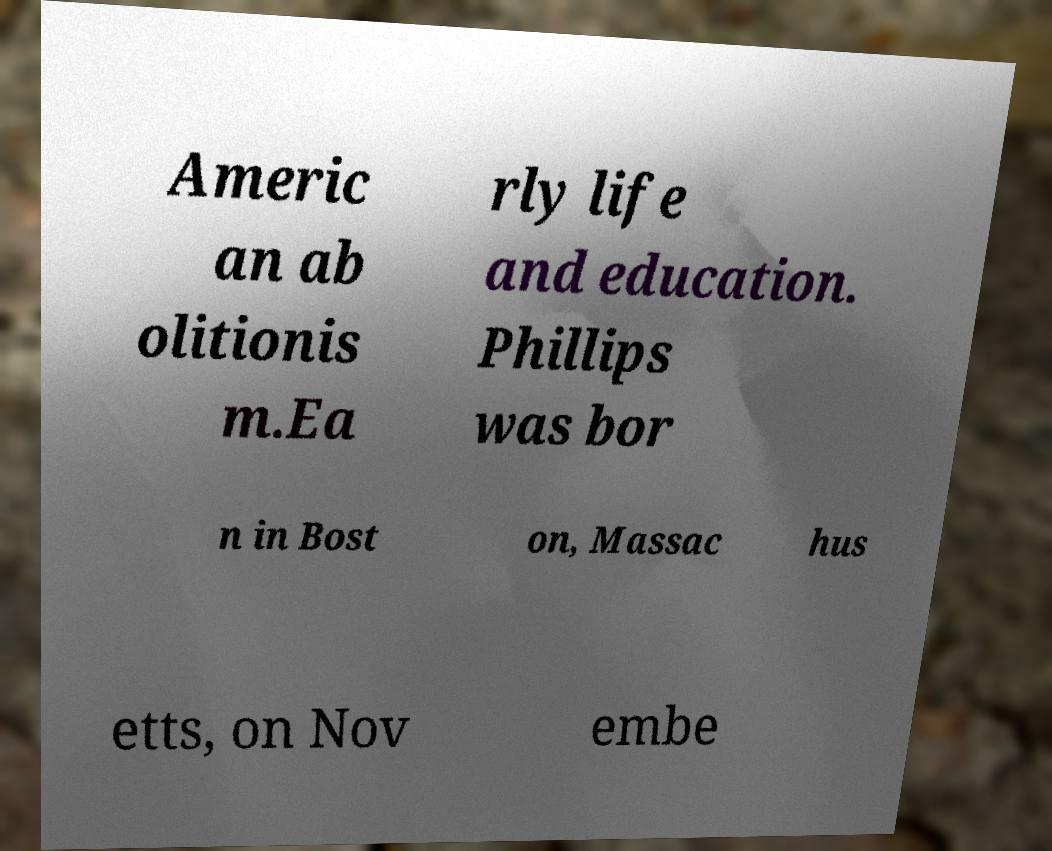Could you extract and type out the text from this image? Americ an ab olitionis m.Ea rly life and education. Phillips was bor n in Bost on, Massac hus etts, on Nov embe 